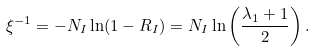Convert formula to latex. <formula><loc_0><loc_0><loc_500><loc_500>\xi ^ { - 1 } = - N _ { I } \ln ( 1 - R _ { I } ) = N _ { I } \ln \left ( \frac { \lambda _ { 1 } + 1 } { 2 } \right ) .</formula> 